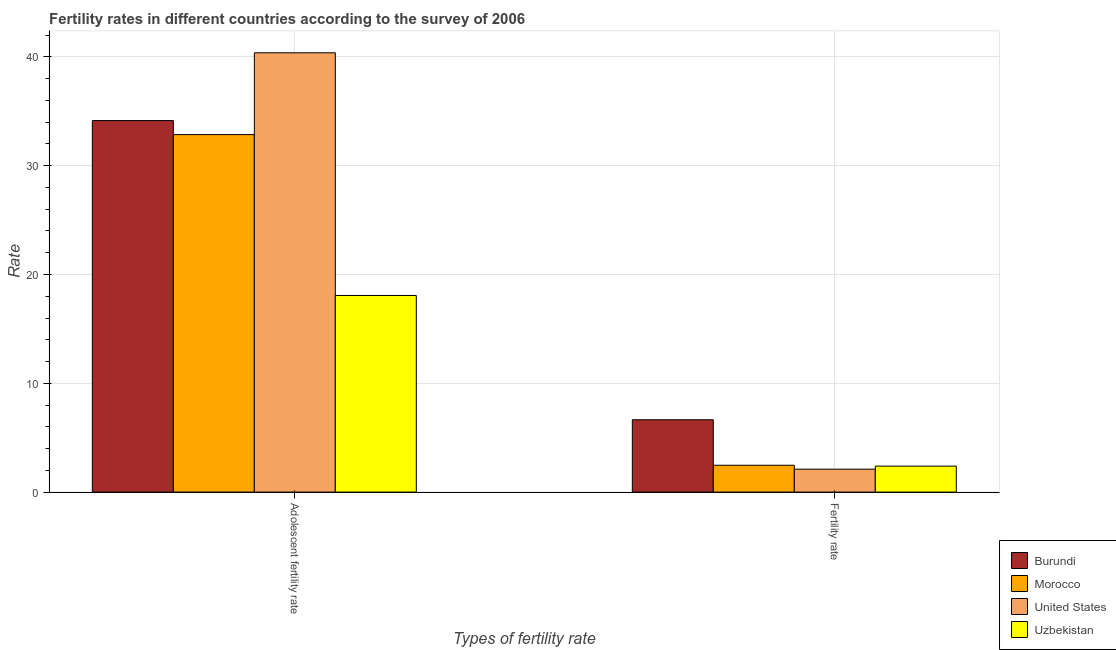How many different coloured bars are there?
Your answer should be very brief. 4. How many groups of bars are there?
Ensure brevity in your answer.  2. How many bars are there on the 1st tick from the left?
Provide a short and direct response. 4. How many bars are there on the 2nd tick from the right?
Your answer should be very brief. 4. What is the label of the 2nd group of bars from the left?
Ensure brevity in your answer.  Fertility rate. What is the fertility rate in Burundi?
Give a very brief answer. 6.65. Across all countries, what is the maximum fertility rate?
Your response must be concise. 6.65. Across all countries, what is the minimum fertility rate?
Your answer should be compact. 2.11. In which country was the fertility rate maximum?
Provide a short and direct response. Burundi. What is the total fertility rate in the graph?
Provide a succinct answer. 13.62. What is the difference between the adolescent fertility rate in Morocco and that in Burundi?
Keep it short and to the point. -1.29. What is the difference between the fertility rate in Uzbekistan and the adolescent fertility rate in Morocco?
Provide a short and direct response. -30.46. What is the average adolescent fertility rate per country?
Give a very brief answer. 31.36. What is the difference between the adolescent fertility rate and fertility rate in Uzbekistan?
Keep it short and to the point. 15.68. In how many countries, is the adolescent fertility rate greater than 36 ?
Make the answer very short. 1. What is the ratio of the adolescent fertility rate in Uzbekistan to that in United States?
Your response must be concise. 0.45. Is the adolescent fertility rate in United States less than that in Morocco?
Offer a terse response. No. In how many countries, is the adolescent fertility rate greater than the average adolescent fertility rate taken over all countries?
Give a very brief answer. 3. What does the 2nd bar from the left in Adolescent fertility rate represents?
Ensure brevity in your answer.  Morocco. What does the 4th bar from the right in Adolescent fertility rate represents?
Your response must be concise. Burundi. Are all the bars in the graph horizontal?
Ensure brevity in your answer.  No. Are the values on the major ticks of Y-axis written in scientific E-notation?
Offer a very short reply. No. Does the graph contain any zero values?
Give a very brief answer. No. Does the graph contain grids?
Your answer should be very brief. Yes. What is the title of the graph?
Provide a short and direct response. Fertility rates in different countries according to the survey of 2006. Does "Italy" appear as one of the legend labels in the graph?
Provide a short and direct response. No. What is the label or title of the X-axis?
Keep it short and to the point. Types of fertility rate. What is the label or title of the Y-axis?
Provide a succinct answer. Rate. What is the Rate of Burundi in Adolescent fertility rate?
Give a very brief answer. 34.14. What is the Rate of Morocco in Adolescent fertility rate?
Provide a succinct answer. 32.85. What is the Rate of United States in Adolescent fertility rate?
Offer a very short reply. 40.38. What is the Rate of Uzbekistan in Adolescent fertility rate?
Ensure brevity in your answer.  18.07. What is the Rate in Burundi in Fertility rate?
Make the answer very short. 6.65. What is the Rate in Morocco in Fertility rate?
Make the answer very short. 2.47. What is the Rate in United States in Fertility rate?
Give a very brief answer. 2.11. What is the Rate in Uzbekistan in Fertility rate?
Give a very brief answer. 2.39. Across all Types of fertility rate, what is the maximum Rate of Burundi?
Provide a short and direct response. 34.14. Across all Types of fertility rate, what is the maximum Rate of Morocco?
Offer a very short reply. 32.85. Across all Types of fertility rate, what is the maximum Rate of United States?
Make the answer very short. 40.38. Across all Types of fertility rate, what is the maximum Rate of Uzbekistan?
Offer a very short reply. 18.07. Across all Types of fertility rate, what is the minimum Rate in Burundi?
Provide a succinct answer. 6.65. Across all Types of fertility rate, what is the minimum Rate in Morocco?
Your answer should be very brief. 2.47. Across all Types of fertility rate, what is the minimum Rate of United States?
Keep it short and to the point. 2.11. Across all Types of fertility rate, what is the minimum Rate in Uzbekistan?
Your response must be concise. 2.39. What is the total Rate of Burundi in the graph?
Your answer should be very brief. 40.79. What is the total Rate in Morocco in the graph?
Offer a terse response. 35.32. What is the total Rate of United States in the graph?
Ensure brevity in your answer.  42.48. What is the total Rate in Uzbekistan in the graph?
Offer a very short reply. 20.46. What is the difference between the Rate of Burundi in Adolescent fertility rate and that in Fertility rate?
Give a very brief answer. 27.5. What is the difference between the Rate of Morocco in Adolescent fertility rate and that in Fertility rate?
Give a very brief answer. 30.39. What is the difference between the Rate in United States in Adolescent fertility rate and that in Fertility rate?
Provide a succinct answer. 38.27. What is the difference between the Rate in Uzbekistan in Adolescent fertility rate and that in Fertility rate?
Offer a very short reply. 15.68. What is the difference between the Rate in Burundi in Adolescent fertility rate and the Rate in Morocco in Fertility rate?
Offer a terse response. 31.68. What is the difference between the Rate in Burundi in Adolescent fertility rate and the Rate in United States in Fertility rate?
Offer a very short reply. 32.04. What is the difference between the Rate of Burundi in Adolescent fertility rate and the Rate of Uzbekistan in Fertility rate?
Your response must be concise. 31.75. What is the difference between the Rate in Morocco in Adolescent fertility rate and the Rate in United States in Fertility rate?
Make the answer very short. 30.75. What is the difference between the Rate of Morocco in Adolescent fertility rate and the Rate of Uzbekistan in Fertility rate?
Your response must be concise. 30.46. What is the difference between the Rate in United States in Adolescent fertility rate and the Rate in Uzbekistan in Fertility rate?
Provide a succinct answer. 37.99. What is the average Rate of Burundi per Types of fertility rate?
Your response must be concise. 20.4. What is the average Rate of Morocco per Types of fertility rate?
Keep it short and to the point. 17.66. What is the average Rate of United States per Types of fertility rate?
Provide a short and direct response. 21.24. What is the average Rate of Uzbekistan per Types of fertility rate?
Ensure brevity in your answer.  10.23. What is the difference between the Rate of Burundi and Rate of Morocco in Adolescent fertility rate?
Provide a short and direct response. 1.29. What is the difference between the Rate in Burundi and Rate in United States in Adolescent fertility rate?
Make the answer very short. -6.23. What is the difference between the Rate in Burundi and Rate in Uzbekistan in Adolescent fertility rate?
Make the answer very short. 16.07. What is the difference between the Rate in Morocco and Rate in United States in Adolescent fertility rate?
Ensure brevity in your answer.  -7.52. What is the difference between the Rate of Morocco and Rate of Uzbekistan in Adolescent fertility rate?
Provide a succinct answer. 14.78. What is the difference between the Rate in United States and Rate in Uzbekistan in Adolescent fertility rate?
Give a very brief answer. 22.3. What is the difference between the Rate of Burundi and Rate of Morocco in Fertility rate?
Offer a terse response. 4.18. What is the difference between the Rate in Burundi and Rate in United States in Fertility rate?
Provide a short and direct response. 4.54. What is the difference between the Rate of Burundi and Rate of Uzbekistan in Fertility rate?
Provide a succinct answer. 4.26. What is the difference between the Rate in Morocco and Rate in United States in Fertility rate?
Offer a terse response. 0.36. What is the difference between the Rate in Morocco and Rate in Uzbekistan in Fertility rate?
Keep it short and to the point. 0.08. What is the difference between the Rate in United States and Rate in Uzbekistan in Fertility rate?
Provide a succinct answer. -0.28. What is the ratio of the Rate in Burundi in Adolescent fertility rate to that in Fertility rate?
Keep it short and to the point. 5.14. What is the ratio of the Rate in Morocco in Adolescent fertility rate to that in Fertility rate?
Your response must be concise. 13.31. What is the ratio of the Rate in United States in Adolescent fertility rate to that in Fertility rate?
Provide a succinct answer. 19.15. What is the ratio of the Rate of Uzbekistan in Adolescent fertility rate to that in Fertility rate?
Offer a very short reply. 7.56. What is the difference between the highest and the second highest Rate in Burundi?
Provide a succinct answer. 27.5. What is the difference between the highest and the second highest Rate of Morocco?
Your response must be concise. 30.39. What is the difference between the highest and the second highest Rate in United States?
Give a very brief answer. 38.27. What is the difference between the highest and the second highest Rate in Uzbekistan?
Provide a short and direct response. 15.68. What is the difference between the highest and the lowest Rate in Burundi?
Your answer should be compact. 27.5. What is the difference between the highest and the lowest Rate in Morocco?
Give a very brief answer. 30.39. What is the difference between the highest and the lowest Rate in United States?
Your response must be concise. 38.27. What is the difference between the highest and the lowest Rate in Uzbekistan?
Offer a very short reply. 15.68. 